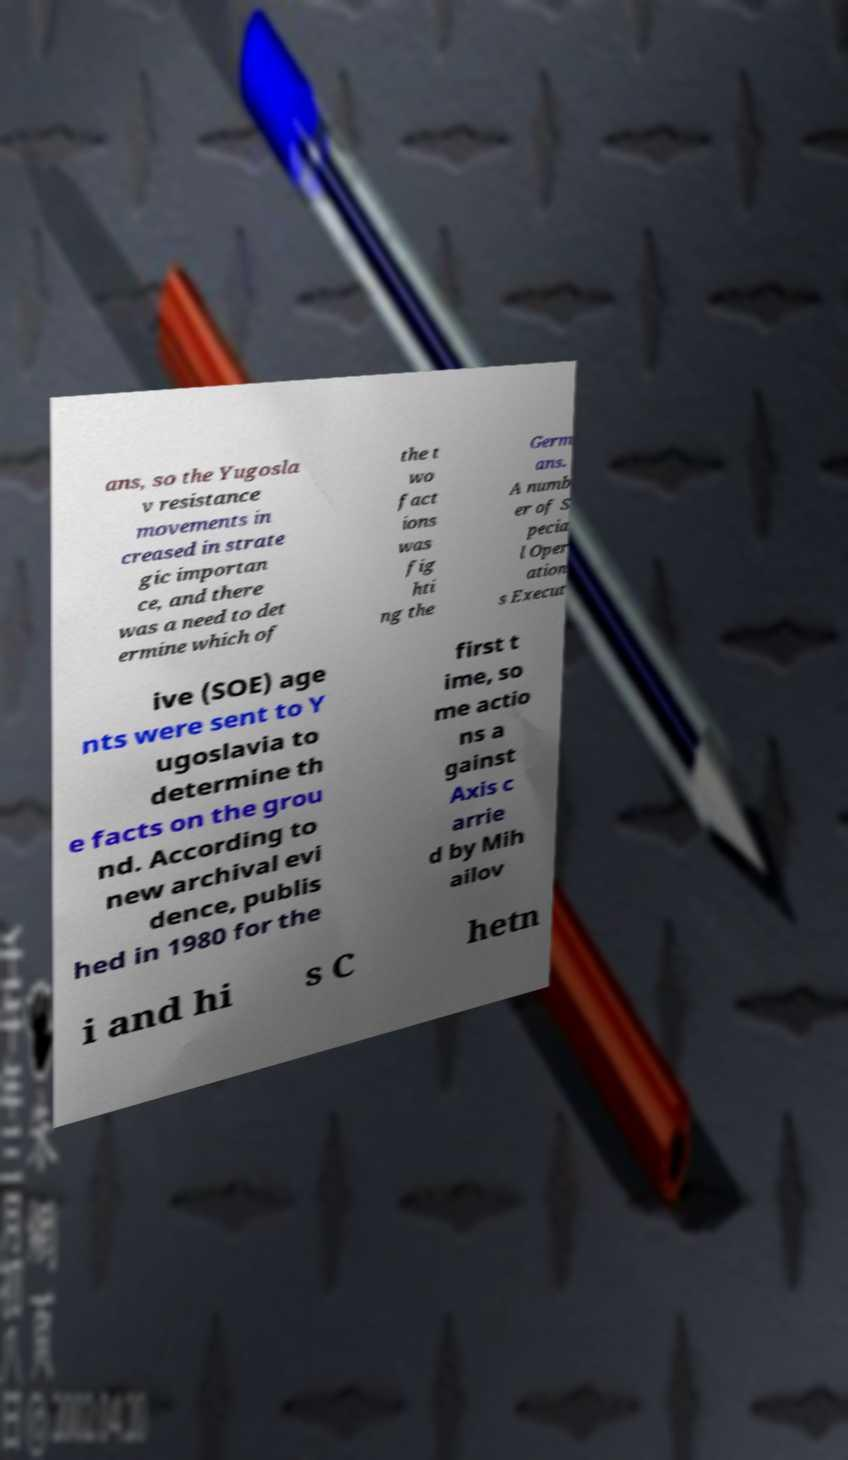Please read and relay the text visible in this image. What does it say? ans, so the Yugosla v resistance movements in creased in strate gic importan ce, and there was a need to det ermine which of the t wo fact ions was fig hti ng the Germ ans. A numb er of S pecia l Oper ation s Execut ive (SOE) age nts were sent to Y ugoslavia to determine th e facts on the grou nd. According to new archival evi dence, publis hed in 1980 for the first t ime, so me actio ns a gainst Axis c arrie d by Mih ailov i and hi s C hetn 